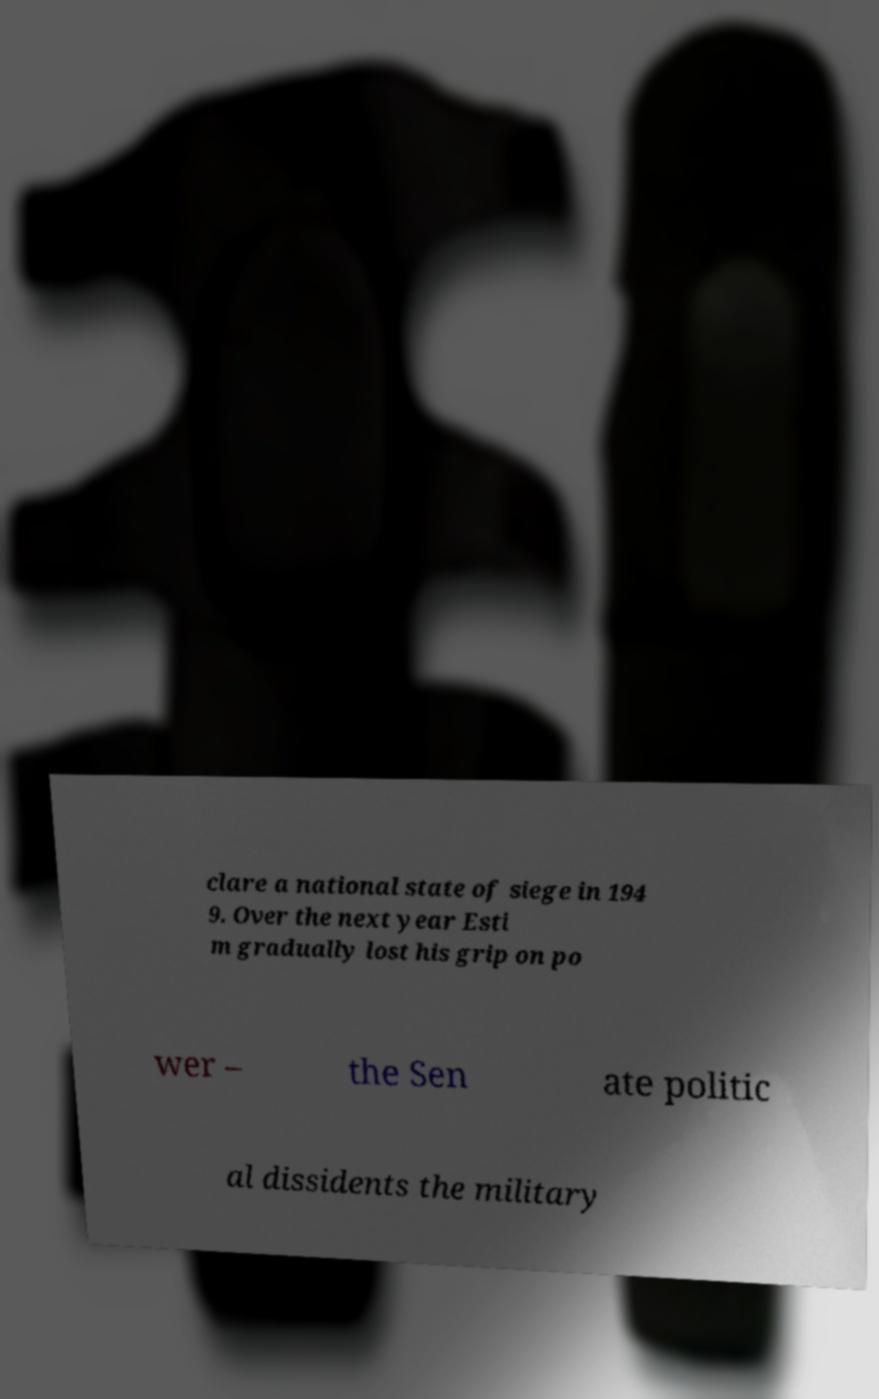There's text embedded in this image that I need extracted. Can you transcribe it verbatim? clare a national state of siege in 194 9. Over the next year Esti m gradually lost his grip on po wer – the Sen ate politic al dissidents the military 